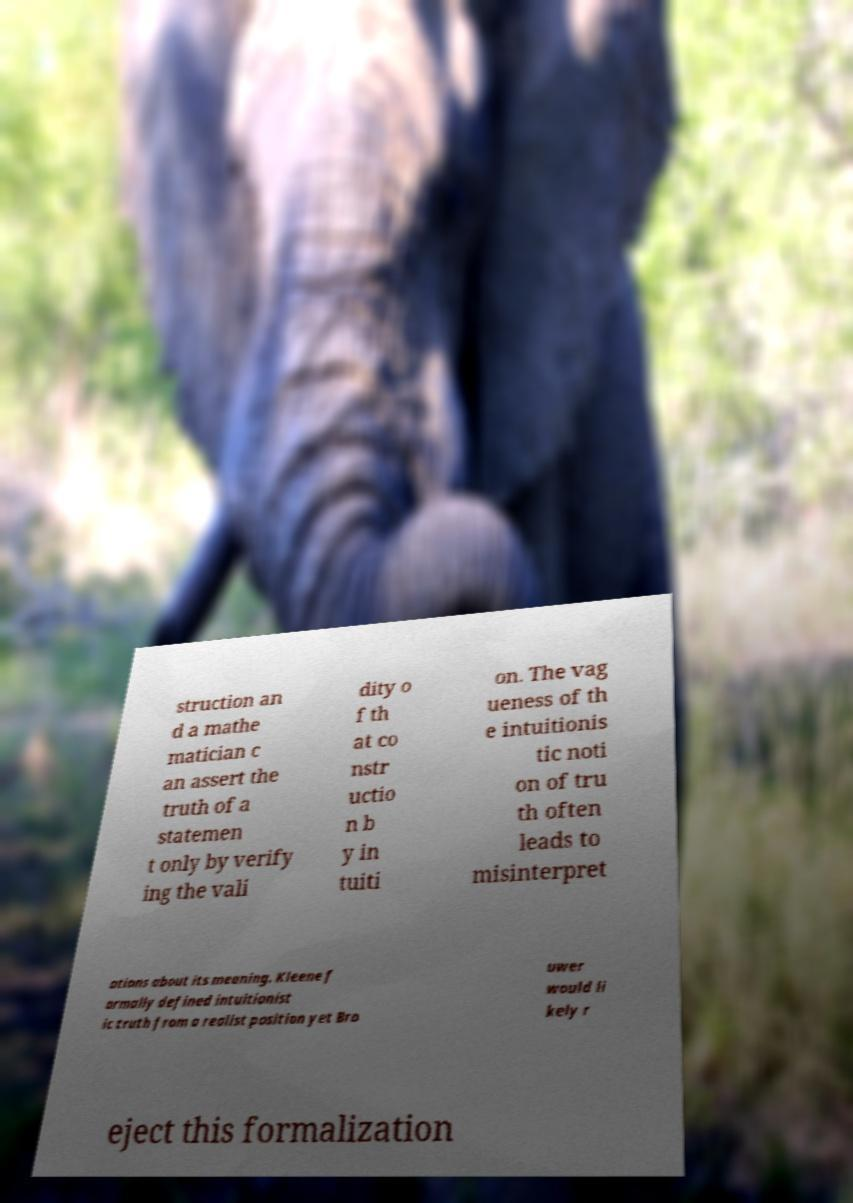There's text embedded in this image that I need extracted. Can you transcribe it verbatim? struction an d a mathe matician c an assert the truth of a statemen t only by verify ing the vali dity o f th at co nstr uctio n b y in tuiti on. The vag ueness of th e intuitionis tic noti on of tru th often leads to misinterpret ations about its meaning. Kleene f ormally defined intuitionist ic truth from a realist position yet Bro uwer would li kely r eject this formalization 